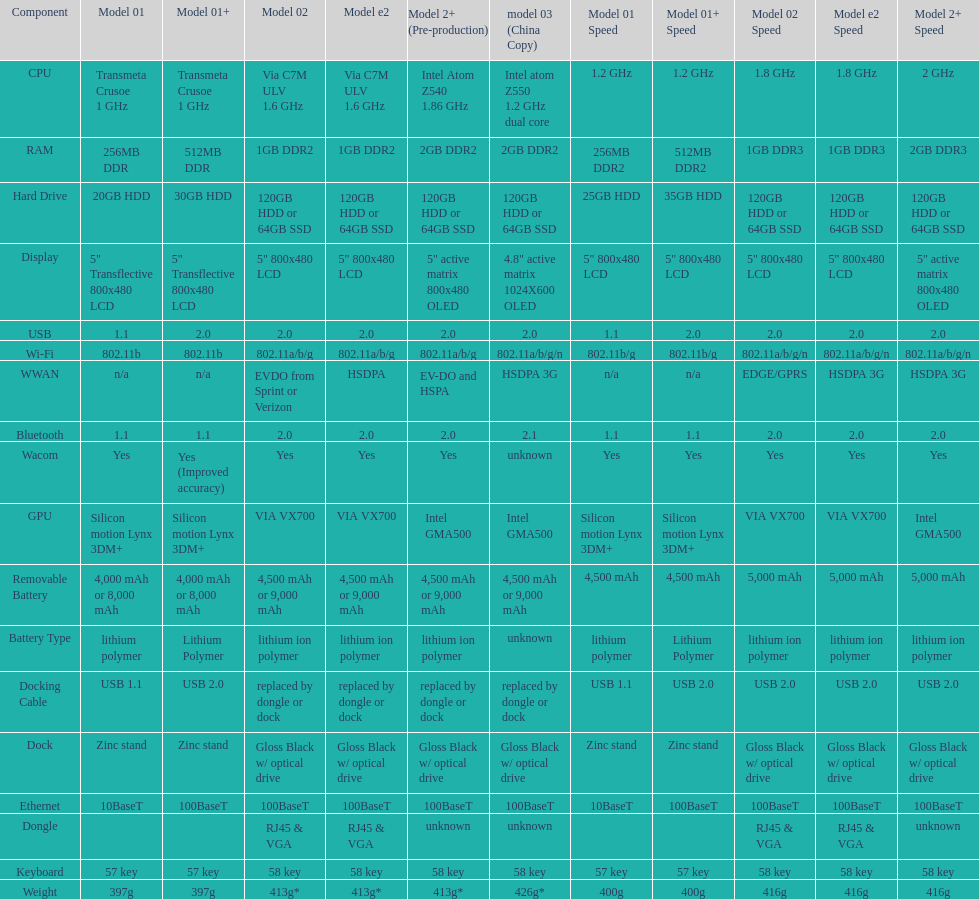How much more weight does the model 3 have over model 1? 29g. Help me parse the entirety of this table. {'header': ['Component', 'Model 01', 'Model 01+', 'Model 02', 'Model e2', 'Model 2+ (Pre-production)', 'model 03 (China Copy)', 'Model 01 Speed', 'Model 01+ Speed', 'Model 02 Speed', 'Model e2 Speed', 'Model 2+ Speed'], 'rows': [['CPU', 'Transmeta Crusoe 1\xa0GHz', 'Transmeta Crusoe 1\xa0GHz', 'Via C7M ULV 1.6\xa0GHz', 'Via C7M ULV 1.6\xa0GHz', 'Intel Atom Z540 1.86\xa0GHz', 'Intel atom Z550 1.2\xa0GHz dual core', '1.2 GHz', '1.2 GHz', '1.8 GHz', '1.8 GHz', '2 GHz'], ['RAM', '256MB DDR', '512MB DDR', '1GB DDR2', '1GB DDR2', '2GB DDR2', '2GB DDR2', '256MB DDR2', '512MB DDR2', '1GB DDR3', '1GB DDR3', '2GB DDR3'], ['Hard Drive', '20GB HDD', '30GB HDD', '120GB HDD or 64GB SSD', '120GB HDD or 64GB SSD', '120GB HDD or 64GB SSD', '120GB HDD or 64GB SSD', '25GB HDD', '35GB HDD', '120GB HDD or 64GB SSD', '120GB HDD or 64GB SSD', '120GB HDD or 64GB SSD'], ['Display', '5" Transflective 800x480 LCD', '5" Transflective 800x480 LCD', '5" 800x480 LCD', '5" 800x480 LCD', '5" active matrix 800x480 OLED', '4.8" active matrix 1024X600 OLED', '5" 800x480 LCD', '5" 800x480 LCD', '5" 800x480 LCD', '5" 800x480 LCD', '5" active matrix 800x480 OLED'], ['USB', '1.1', '2.0', '2.0', '2.0', '2.0', '2.0', '1.1', '2.0', '2.0', '2.0', '2.0'], ['Wi-Fi', '802.11b', '802.11b', '802.11a/b/g', '802.11a/b/g', '802.11a/b/g', '802.11a/b/g/n', '802.11b/g', '802.11b/g', '802.11a/b/g/n', '802.11a/b/g/n', '802.11a/b/g/n'], ['WWAN', 'n/a', 'n/a', 'EVDO from Sprint or Verizon', 'HSDPA', 'EV-DO and HSPA', 'HSDPA 3G', 'n/a', 'n/a', 'EDGE/GPRS', 'HSDPA 3G', 'HSDPA 3G'], ['Bluetooth', '1.1', '1.1', '2.0', '2.0', '2.0', '2.1', '1.1', '1.1', '2.0', '2.0', '2.0'], ['Wacom', 'Yes', 'Yes (Improved accuracy)', 'Yes', 'Yes', 'Yes', 'unknown', 'Yes', 'Yes', 'Yes', 'Yes', 'Yes'], ['GPU', 'Silicon motion Lynx 3DM+', 'Silicon motion Lynx 3DM+', 'VIA VX700', 'VIA VX700', 'Intel GMA500', 'Intel GMA500', 'Silicon motion Lynx 3DM+', 'Silicon motion Lynx 3DM+', 'VIA VX700', 'VIA VX700', 'Intel GMA500'], ['Removable Battery', '4,000 mAh or 8,000 mAh', '4,000 mAh or 8,000 mAh', '4,500 mAh or 9,000 mAh', '4,500 mAh or 9,000 mAh', '4,500 mAh or 9,000 mAh', '4,500 mAh or 9,000 mAh', '4,500 mAh', '4,500 mAh', '5,000 mAh', '5,000 mAh', '5,000 mAh'], ['Battery Type', 'lithium polymer', 'Lithium Polymer', 'lithium ion polymer', 'lithium ion polymer', 'lithium ion polymer', 'unknown', 'lithium polymer', 'Lithium Polymer', 'lithium ion polymer', 'lithium ion polymer', 'lithium ion polymer'], ['Docking Cable', 'USB 1.1', 'USB 2.0', 'replaced by dongle or dock', 'replaced by dongle or dock', 'replaced by dongle or dock', 'replaced by dongle or dock', 'USB 1.1', 'USB 2.0', 'USB 2.0', 'USB 2.0', 'USB 2.0'], ['Dock', 'Zinc stand', 'Zinc stand', 'Gloss Black w/ optical drive', 'Gloss Black w/ optical drive', 'Gloss Black w/ optical drive', 'Gloss Black w/ optical drive', 'Zinc stand', 'Zinc stand', 'Gloss Black w/ optical drive', 'Gloss Black w/ optical drive', 'Gloss Black w/ optical drive'], ['Ethernet', '10BaseT', '100BaseT', '100BaseT', '100BaseT', '100BaseT', '100BaseT', '10BaseT', '100BaseT', '100BaseT', '100BaseT', '100BaseT'], ['Dongle', '', '', 'RJ45 & VGA', 'RJ45 & VGA', 'unknown', 'unknown', '', '', 'RJ45 & VGA', 'RJ45 & VGA', 'unknown'], ['Keyboard', '57 key', '57 key', '58 key', '58 key', '58 key', '58 key', '57 key', '57 key', '58 key', '58 key', '58 key'], ['Weight', '397g', '397g', '413g*', '413g*', '413g*', '426g*', '400g', '400g', '416g', '416g', '416g']]} 